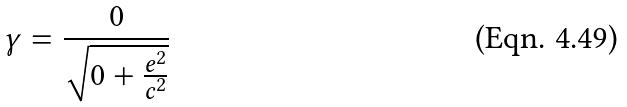Convert formula to latex. <formula><loc_0><loc_0><loc_500><loc_500>\gamma = \frac { 0 } { \sqrt { 0 + \frac { e ^ { 2 } } { c ^ { 2 } } } }</formula> 